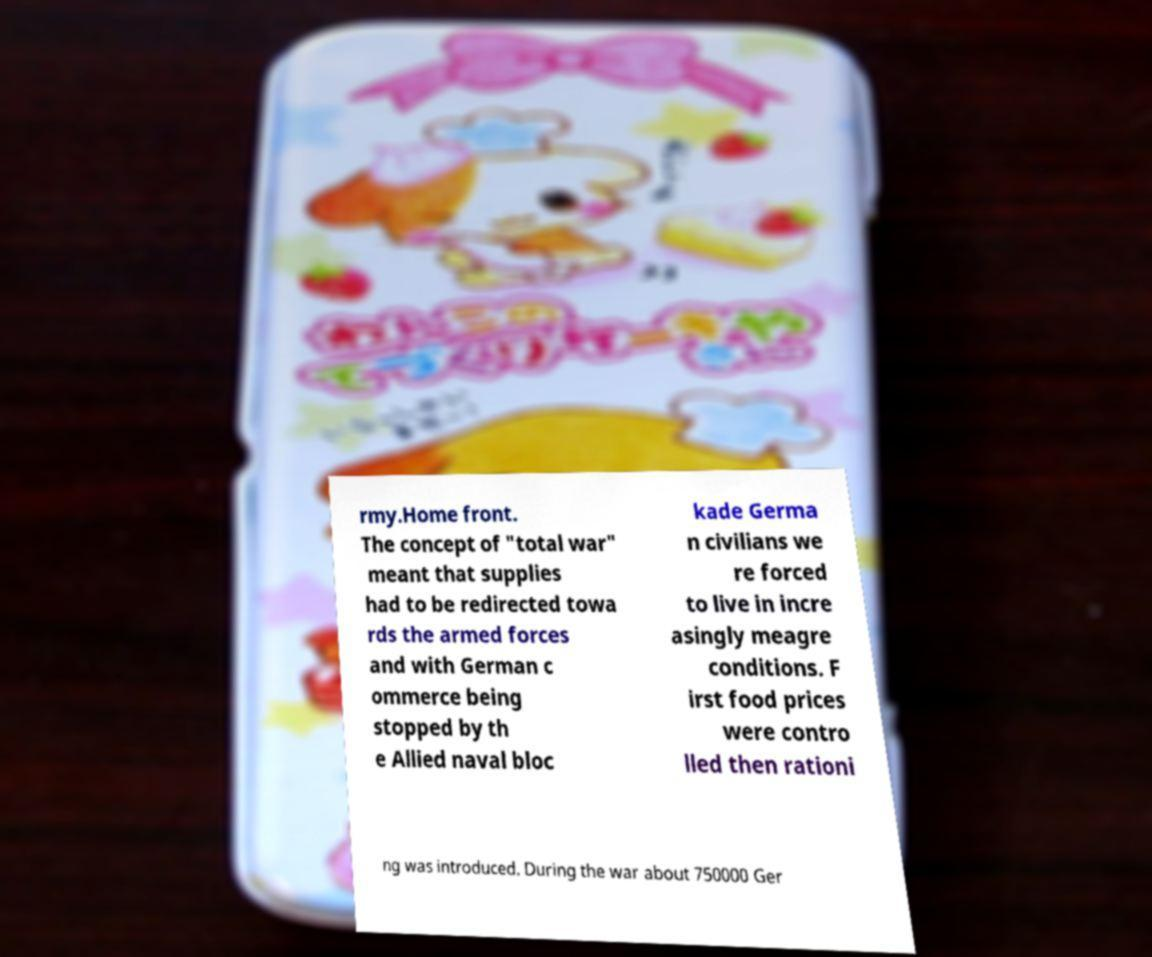There's text embedded in this image that I need extracted. Can you transcribe it verbatim? rmy.Home front. The concept of "total war" meant that supplies had to be redirected towa rds the armed forces and with German c ommerce being stopped by th e Allied naval bloc kade Germa n civilians we re forced to live in incre asingly meagre conditions. F irst food prices were contro lled then rationi ng was introduced. During the war about 750000 Ger 